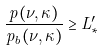Convert formula to latex. <formula><loc_0><loc_0><loc_500><loc_500>\frac { p ( \nu , \kappa ) } { p _ { b } ( \nu , \kappa ) } \geq L _ { * } ^ { \prime }</formula> 